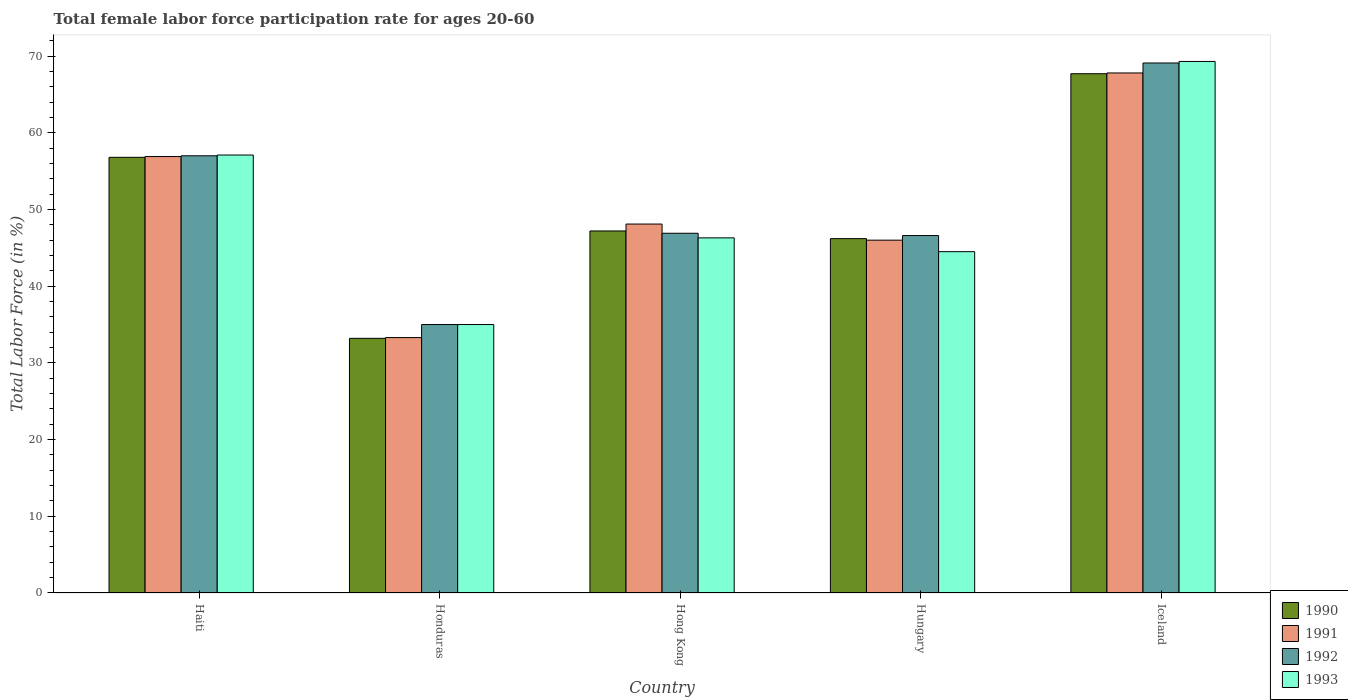How many groups of bars are there?
Your response must be concise. 5. What is the label of the 1st group of bars from the left?
Provide a short and direct response. Haiti. In how many cases, is the number of bars for a given country not equal to the number of legend labels?
Offer a terse response. 0. What is the female labor force participation rate in 1991 in Iceland?
Make the answer very short. 67.8. Across all countries, what is the maximum female labor force participation rate in 1990?
Make the answer very short. 67.7. In which country was the female labor force participation rate in 1991 minimum?
Provide a succinct answer. Honduras. What is the total female labor force participation rate in 1991 in the graph?
Your response must be concise. 252.1. What is the difference between the female labor force participation rate in 1993 in Hong Kong and that in Hungary?
Offer a terse response. 1.8. What is the difference between the female labor force participation rate in 1990 in Hungary and the female labor force participation rate in 1993 in Iceland?
Provide a short and direct response. -23.1. What is the average female labor force participation rate in 1990 per country?
Your answer should be compact. 50.22. What is the difference between the female labor force participation rate of/in 1993 and female labor force participation rate of/in 1992 in Hong Kong?
Your answer should be very brief. -0.6. In how many countries, is the female labor force participation rate in 1991 greater than 20 %?
Your answer should be very brief. 5. What is the ratio of the female labor force participation rate in 1990 in Haiti to that in Iceland?
Your answer should be compact. 0.84. Is the female labor force participation rate in 1991 in Haiti less than that in Honduras?
Your response must be concise. No. Is the difference between the female labor force participation rate in 1993 in Hungary and Iceland greater than the difference between the female labor force participation rate in 1992 in Hungary and Iceland?
Your answer should be very brief. No. What is the difference between the highest and the second highest female labor force participation rate in 1992?
Your answer should be very brief. -12.1. What is the difference between the highest and the lowest female labor force participation rate in 1992?
Offer a terse response. 34.1. In how many countries, is the female labor force participation rate in 1991 greater than the average female labor force participation rate in 1991 taken over all countries?
Your answer should be compact. 2. Is the sum of the female labor force participation rate in 1991 in Honduras and Hong Kong greater than the maximum female labor force participation rate in 1992 across all countries?
Your answer should be very brief. Yes. What does the 4th bar from the left in Honduras represents?
Your answer should be compact. 1993. What does the 1st bar from the right in Hungary represents?
Provide a short and direct response. 1993. How many countries are there in the graph?
Offer a terse response. 5. What is the difference between two consecutive major ticks on the Y-axis?
Keep it short and to the point. 10. Are the values on the major ticks of Y-axis written in scientific E-notation?
Make the answer very short. No. Does the graph contain any zero values?
Provide a short and direct response. No. Does the graph contain grids?
Give a very brief answer. No. Where does the legend appear in the graph?
Offer a terse response. Bottom right. What is the title of the graph?
Give a very brief answer. Total female labor force participation rate for ages 20-60. Does "2002" appear as one of the legend labels in the graph?
Your response must be concise. No. What is the Total Labor Force (in %) of 1990 in Haiti?
Give a very brief answer. 56.8. What is the Total Labor Force (in %) of 1991 in Haiti?
Keep it short and to the point. 56.9. What is the Total Labor Force (in %) in 1992 in Haiti?
Give a very brief answer. 57. What is the Total Labor Force (in %) in 1993 in Haiti?
Your answer should be compact. 57.1. What is the Total Labor Force (in %) in 1990 in Honduras?
Offer a very short reply. 33.2. What is the Total Labor Force (in %) of 1991 in Honduras?
Provide a succinct answer. 33.3. What is the Total Labor Force (in %) of 1993 in Honduras?
Give a very brief answer. 35. What is the Total Labor Force (in %) of 1990 in Hong Kong?
Your answer should be compact. 47.2. What is the Total Labor Force (in %) in 1991 in Hong Kong?
Provide a short and direct response. 48.1. What is the Total Labor Force (in %) in 1992 in Hong Kong?
Your answer should be compact. 46.9. What is the Total Labor Force (in %) in 1993 in Hong Kong?
Make the answer very short. 46.3. What is the Total Labor Force (in %) in 1990 in Hungary?
Offer a very short reply. 46.2. What is the Total Labor Force (in %) of 1992 in Hungary?
Your response must be concise. 46.6. What is the Total Labor Force (in %) of 1993 in Hungary?
Offer a terse response. 44.5. What is the Total Labor Force (in %) of 1990 in Iceland?
Make the answer very short. 67.7. What is the Total Labor Force (in %) of 1991 in Iceland?
Make the answer very short. 67.8. What is the Total Labor Force (in %) in 1992 in Iceland?
Your answer should be compact. 69.1. What is the Total Labor Force (in %) of 1993 in Iceland?
Give a very brief answer. 69.3. Across all countries, what is the maximum Total Labor Force (in %) in 1990?
Your answer should be very brief. 67.7. Across all countries, what is the maximum Total Labor Force (in %) in 1991?
Give a very brief answer. 67.8. Across all countries, what is the maximum Total Labor Force (in %) of 1992?
Provide a succinct answer. 69.1. Across all countries, what is the maximum Total Labor Force (in %) of 1993?
Provide a succinct answer. 69.3. Across all countries, what is the minimum Total Labor Force (in %) in 1990?
Offer a very short reply. 33.2. Across all countries, what is the minimum Total Labor Force (in %) in 1991?
Make the answer very short. 33.3. Across all countries, what is the minimum Total Labor Force (in %) of 1993?
Offer a very short reply. 35. What is the total Total Labor Force (in %) of 1990 in the graph?
Ensure brevity in your answer.  251.1. What is the total Total Labor Force (in %) of 1991 in the graph?
Offer a very short reply. 252.1. What is the total Total Labor Force (in %) in 1992 in the graph?
Your answer should be very brief. 254.6. What is the total Total Labor Force (in %) of 1993 in the graph?
Keep it short and to the point. 252.2. What is the difference between the Total Labor Force (in %) in 1990 in Haiti and that in Honduras?
Offer a very short reply. 23.6. What is the difference between the Total Labor Force (in %) of 1991 in Haiti and that in Honduras?
Offer a terse response. 23.6. What is the difference between the Total Labor Force (in %) of 1992 in Haiti and that in Honduras?
Give a very brief answer. 22. What is the difference between the Total Labor Force (in %) in 1993 in Haiti and that in Honduras?
Provide a succinct answer. 22.1. What is the difference between the Total Labor Force (in %) in 1991 in Haiti and that in Hong Kong?
Keep it short and to the point. 8.8. What is the difference between the Total Labor Force (in %) in 1992 in Haiti and that in Hong Kong?
Provide a succinct answer. 10.1. What is the difference between the Total Labor Force (in %) of 1993 in Haiti and that in Hong Kong?
Provide a succinct answer. 10.8. What is the difference between the Total Labor Force (in %) of 1990 in Haiti and that in Hungary?
Give a very brief answer. 10.6. What is the difference between the Total Labor Force (in %) of 1993 in Haiti and that in Hungary?
Give a very brief answer. 12.6. What is the difference between the Total Labor Force (in %) in 1991 in Haiti and that in Iceland?
Your answer should be compact. -10.9. What is the difference between the Total Labor Force (in %) in 1992 in Haiti and that in Iceland?
Offer a terse response. -12.1. What is the difference between the Total Labor Force (in %) of 1993 in Haiti and that in Iceland?
Your answer should be very brief. -12.2. What is the difference between the Total Labor Force (in %) in 1991 in Honduras and that in Hong Kong?
Provide a succinct answer. -14.8. What is the difference between the Total Labor Force (in %) of 1992 in Honduras and that in Hungary?
Offer a very short reply. -11.6. What is the difference between the Total Labor Force (in %) of 1993 in Honduras and that in Hungary?
Your answer should be compact. -9.5. What is the difference between the Total Labor Force (in %) of 1990 in Honduras and that in Iceland?
Ensure brevity in your answer.  -34.5. What is the difference between the Total Labor Force (in %) in 1991 in Honduras and that in Iceland?
Keep it short and to the point. -34.5. What is the difference between the Total Labor Force (in %) of 1992 in Honduras and that in Iceland?
Offer a very short reply. -34.1. What is the difference between the Total Labor Force (in %) in 1993 in Honduras and that in Iceland?
Offer a terse response. -34.3. What is the difference between the Total Labor Force (in %) in 1991 in Hong Kong and that in Hungary?
Offer a terse response. 2.1. What is the difference between the Total Labor Force (in %) in 1992 in Hong Kong and that in Hungary?
Your answer should be very brief. 0.3. What is the difference between the Total Labor Force (in %) of 1990 in Hong Kong and that in Iceland?
Provide a succinct answer. -20.5. What is the difference between the Total Labor Force (in %) of 1991 in Hong Kong and that in Iceland?
Ensure brevity in your answer.  -19.7. What is the difference between the Total Labor Force (in %) in 1992 in Hong Kong and that in Iceland?
Keep it short and to the point. -22.2. What is the difference between the Total Labor Force (in %) of 1993 in Hong Kong and that in Iceland?
Your answer should be very brief. -23. What is the difference between the Total Labor Force (in %) in 1990 in Hungary and that in Iceland?
Make the answer very short. -21.5. What is the difference between the Total Labor Force (in %) in 1991 in Hungary and that in Iceland?
Make the answer very short. -21.8. What is the difference between the Total Labor Force (in %) in 1992 in Hungary and that in Iceland?
Keep it short and to the point. -22.5. What is the difference between the Total Labor Force (in %) in 1993 in Hungary and that in Iceland?
Provide a succinct answer. -24.8. What is the difference between the Total Labor Force (in %) in 1990 in Haiti and the Total Labor Force (in %) in 1992 in Honduras?
Offer a terse response. 21.8. What is the difference between the Total Labor Force (in %) of 1990 in Haiti and the Total Labor Force (in %) of 1993 in Honduras?
Offer a terse response. 21.8. What is the difference between the Total Labor Force (in %) in 1991 in Haiti and the Total Labor Force (in %) in 1992 in Honduras?
Offer a very short reply. 21.9. What is the difference between the Total Labor Force (in %) in 1991 in Haiti and the Total Labor Force (in %) in 1993 in Honduras?
Give a very brief answer. 21.9. What is the difference between the Total Labor Force (in %) in 1992 in Haiti and the Total Labor Force (in %) in 1993 in Honduras?
Give a very brief answer. 22. What is the difference between the Total Labor Force (in %) of 1990 in Haiti and the Total Labor Force (in %) of 1993 in Hong Kong?
Keep it short and to the point. 10.5. What is the difference between the Total Labor Force (in %) of 1992 in Haiti and the Total Labor Force (in %) of 1993 in Hong Kong?
Keep it short and to the point. 10.7. What is the difference between the Total Labor Force (in %) in 1990 in Haiti and the Total Labor Force (in %) in 1991 in Hungary?
Offer a very short reply. 10.8. What is the difference between the Total Labor Force (in %) in 1990 in Haiti and the Total Labor Force (in %) in 1992 in Hungary?
Make the answer very short. 10.2. What is the difference between the Total Labor Force (in %) in 1991 in Haiti and the Total Labor Force (in %) in 1992 in Hungary?
Provide a succinct answer. 10.3. What is the difference between the Total Labor Force (in %) of 1990 in Haiti and the Total Labor Force (in %) of 1992 in Iceland?
Your response must be concise. -12.3. What is the difference between the Total Labor Force (in %) of 1990 in Haiti and the Total Labor Force (in %) of 1993 in Iceland?
Offer a terse response. -12.5. What is the difference between the Total Labor Force (in %) of 1991 in Haiti and the Total Labor Force (in %) of 1993 in Iceland?
Offer a terse response. -12.4. What is the difference between the Total Labor Force (in %) of 1992 in Haiti and the Total Labor Force (in %) of 1993 in Iceland?
Offer a very short reply. -12.3. What is the difference between the Total Labor Force (in %) in 1990 in Honduras and the Total Labor Force (in %) in 1991 in Hong Kong?
Your answer should be compact. -14.9. What is the difference between the Total Labor Force (in %) of 1990 in Honduras and the Total Labor Force (in %) of 1992 in Hong Kong?
Make the answer very short. -13.7. What is the difference between the Total Labor Force (in %) of 1990 in Honduras and the Total Labor Force (in %) of 1993 in Hong Kong?
Give a very brief answer. -13.1. What is the difference between the Total Labor Force (in %) of 1991 in Honduras and the Total Labor Force (in %) of 1992 in Hong Kong?
Keep it short and to the point. -13.6. What is the difference between the Total Labor Force (in %) of 1991 in Honduras and the Total Labor Force (in %) of 1993 in Hong Kong?
Offer a terse response. -13. What is the difference between the Total Labor Force (in %) in 1992 in Honduras and the Total Labor Force (in %) in 1993 in Hong Kong?
Provide a short and direct response. -11.3. What is the difference between the Total Labor Force (in %) of 1990 in Honduras and the Total Labor Force (in %) of 1992 in Hungary?
Give a very brief answer. -13.4. What is the difference between the Total Labor Force (in %) in 1990 in Honduras and the Total Labor Force (in %) in 1993 in Hungary?
Your answer should be compact. -11.3. What is the difference between the Total Labor Force (in %) of 1992 in Honduras and the Total Labor Force (in %) of 1993 in Hungary?
Provide a succinct answer. -9.5. What is the difference between the Total Labor Force (in %) in 1990 in Honduras and the Total Labor Force (in %) in 1991 in Iceland?
Your answer should be compact. -34.6. What is the difference between the Total Labor Force (in %) in 1990 in Honduras and the Total Labor Force (in %) in 1992 in Iceland?
Provide a succinct answer. -35.9. What is the difference between the Total Labor Force (in %) of 1990 in Honduras and the Total Labor Force (in %) of 1993 in Iceland?
Provide a short and direct response. -36.1. What is the difference between the Total Labor Force (in %) in 1991 in Honduras and the Total Labor Force (in %) in 1992 in Iceland?
Your answer should be compact. -35.8. What is the difference between the Total Labor Force (in %) of 1991 in Honduras and the Total Labor Force (in %) of 1993 in Iceland?
Offer a terse response. -36. What is the difference between the Total Labor Force (in %) of 1992 in Honduras and the Total Labor Force (in %) of 1993 in Iceland?
Keep it short and to the point. -34.3. What is the difference between the Total Labor Force (in %) in 1990 in Hong Kong and the Total Labor Force (in %) in 1992 in Hungary?
Make the answer very short. 0.6. What is the difference between the Total Labor Force (in %) of 1990 in Hong Kong and the Total Labor Force (in %) of 1993 in Hungary?
Offer a terse response. 2.7. What is the difference between the Total Labor Force (in %) in 1991 in Hong Kong and the Total Labor Force (in %) in 1993 in Hungary?
Ensure brevity in your answer.  3.6. What is the difference between the Total Labor Force (in %) in 1992 in Hong Kong and the Total Labor Force (in %) in 1993 in Hungary?
Make the answer very short. 2.4. What is the difference between the Total Labor Force (in %) in 1990 in Hong Kong and the Total Labor Force (in %) in 1991 in Iceland?
Your answer should be compact. -20.6. What is the difference between the Total Labor Force (in %) of 1990 in Hong Kong and the Total Labor Force (in %) of 1992 in Iceland?
Your response must be concise. -21.9. What is the difference between the Total Labor Force (in %) of 1990 in Hong Kong and the Total Labor Force (in %) of 1993 in Iceland?
Offer a terse response. -22.1. What is the difference between the Total Labor Force (in %) of 1991 in Hong Kong and the Total Labor Force (in %) of 1993 in Iceland?
Provide a succinct answer. -21.2. What is the difference between the Total Labor Force (in %) of 1992 in Hong Kong and the Total Labor Force (in %) of 1993 in Iceland?
Give a very brief answer. -22.4. What is the difference between the Total Labor Force (in %) in 1990 in Hungary and the Total Labor Force (in %) in 1991 in Iceland?
Offer a very short reply. -21.6. What is the difference between the Total Labor Force (in %) of 1990 in Hungary and the Total Labor Force (in %) of 1992 in Iceland?
Offer a terse response. -22.9. What is the difference between the Total Labor Force (in %) of 1990 in Hungary and the Total Labor Force (in %) of 1993 in Iceland?
Offer a very short reply. -23.1. What is the difference between the Total Labor Force (in %) in 1991 in Hungary and the Total Labor Force (in %) in 1992 in Iceland?
Provide a succinct answer. -23.1. What is the difference between the Total Labor Force (in %) in 1991 in Hungary and the Total Labor Force (in %) in 1993 in Iceland?
Offer a terse response. -23.3. What is the difference between the Total Labor Force (in %) in 1992 in Hungary and the Total Labor Force (in %) in 1993 in Iceland?
Give a very brief answer. -22.7. What is the average Total Labor Force (in %) of 1990 per country?
Give a very brief answer. 50.22. What is the average Total Labor Force (in %) of 1991 per country?
Your response must be concise. 50.42. What is the average Total Labor Force (in %) of 1992 per country?
Your response must be concise. 50.92. What is the average Total Labor Force (in %) in 1993 per country?
Ensure brevity in your answer.  50.44. What is the difference between the Total Labor Force (in %) in 1990 and Total Labor Force (in %) in 1993 in Haiti?
Your answer should be very brief. -0.3. What is the difference between the Total Labor Force (in %) of 1991 and Total Labor Force (in %) of 1993 in Haiti?
Make the answer very short. -0.2. What is the difference between the Total Labor Force (in %) in 1992 and Total Labor Force (in %) in 1993 in Haiti?
Make the answer very short. -0.1. What is the difference between the Total Labor Force (in %) in 1990 and Total Labor Force (in %) in 1991 in Honduras?
Give a very brief answer. -0.1. What is the difference between the Total Labor Force (in %) of 1990 and Total Labor Force (in %) of 1992 in Honduras?
Your answer should be compact. -1.8. What is the difference between the Total Labor Force (in %) of 1991 and Total Labor Force (in %) of 1992 in Honduras?
Your answer should be compact. -1.7. What is the difference between the Total Labor Force (in %) of 1992 and Total Labor Force (in %) of 1993 in Honduras?
Offer a terse response. 0. What is the difference between the Total Labor Force (in %) in 1990 and Total Labor Force (in %) in 1993 in Hong Kong?
Ensure brevity in your answer.  0.9. What is the difference between the Total Labor Force (in %) in 1991 and Total Labor Force (in %) in 1993 in Hong Kong?
Provide a short and direct response. 1.8. What is the difference between the Total Labor Force (in %) of 1992 and Total Labor Force (in %) of 1993 in Hong Kong?
Your response must be concise. 0.6. What is the difference between the Total Labor Force (in %) of 1990 and Total Labor Force (in %) of 1991 in Hungary?
Provide a short and direct response. 0.2. What is the difference between the Total Labor Force (in %) in 1990 and Total Labor Force (in %) in 1992 in Hungary?
Offer a terse response. -0.4. What is the difference between the Total Labor Force (in %) in 1991 and Total Labor Force (in %) in 1992 in Hungary?
Provide a succinct answer. -0.6. What is the difference between the Total Labor Force (in %) of 1991 and Total Labor Force (in %) of 1993 in Hungary?
Your response must be concise. 1.5. What is the difference between the Total Labor Force (in %) in 1992 and Total Labor Force (in %) in 1993 in Hungary?
Make the answer very short. 2.1. What is the difference between the Total Labor Force (in %) of 1990 and Total Labor Force (in %) of 1992 in Iceland?
Make the answer very short. -1.4. What is the difference between the Total Labor Force (in %) of 1990 and Total Labor Force (in %) of 1993 in Iceland?
Your response must be concise. -1.6. What is the ratio of the Total Labor Force (in %) of 1990 in Haiti to that in Honduras?
Offer a terse response. 1.71. What is the ratio of the Total Labor Force (in %) of 1991 in Haiti to that in Honduras?
Provide a succinct answer. 1.71. What is the ratio of the Total Labor Force (in %) of 1992 in Haiti to that in Honduras?
Ensure brevity in your answer.  1.63. What is the ratio of the Total Labor Force (in %) of 1993 in Haiti to that in Honduras?
Give a very brief answer. 1.63. What is the ratio of the Total Labor Force (in %) in 1990 in Haiti to that in Hong Kong?
Make the answer very short. 1.2. What is the ratio of the Total Labor Force (in %) in 1991 in Haiti to that in Hong Kong?
Offer a very short reply. 1.18. What is the ratio of the Total Labor Force (in %) of 1992 in Haiti to that in Hong Kong?
Provide a succinct answer. 1.22. What is the ratio of the Total Labor Force (in %) of 1993 in Haiti to that in Hong Kong?
Offer a very short reply. 1.23. What is the ratio of the Total Labor Force (in %) of 1990 in Haiti to that in Hungary?
Offer a terse response. 1.23. What is the ratio of the Total Labor Force (in %) in 1991 in Haiti to that in Hungary?
Offer a very short reply. 1.24. What is the ratio of the Total Labor Force (in %) of 1992 in Haiti to that in Hungary?
Ensure brevity in your answer.  1.22. What is the ratio of the Total Labor Force (in %) of 1993 in Haiti to that in Hungary?
Ensure brevity in your answer.  1.28. What is the ratio of the Total Labor Force (in %) in 1990 in Haiti to that in Iceland?
Make the answer very short. 0.84. What is the ratio of the Total Labor Force (in %) in 1991 in Haiti to that in Iceland?
Ensure brevity in your answer.  0.84. What is the ratio of the Total Labor Force (in %) in 1992 in Haiti to that in Iceland?
Provide a short and direct response. 0.82. What is the ratio of the Total Labor Force (in %) of 1993 in Haiti to that in Iceland?
Provide a short and direct response. 0.82. What is the ratio of the Total Labor Force (in %) in 1990 in Honduras to that in Hong Kong?
Make the answer very short. 0.7. What is the ratio of the Total Labor Force (in %) of 1991 in Honduras to that in Hong Kong?
Give a very brief answer. 0.69. What is the ratio of the Total Labor Force (in %) in 1992 in Honduras to that in Hong Kong?
Ensure brevity in your answer.  0.75. What is the ratio of the Total Labor Force (in %) in 1993 in Honduras to that in Hong Kong?
Your response must be concise. 0.76. What is the ratio of the Total Labor Force (in %) of 1990 in Honduras to that in Hungary?
Your answer should be very brief. 0.72. What is the ratio of the Total Labor Force (in %) in 1991 in Honduras to that in Hungary?
Offer a very short reply. 0.72. What is the ratio of the Total Labor Force (in %) in 1992 in Honduras to that in Hungary?
Provide a short and direct response. 0.75. What is the ratio of the Total Labor Force (in %) of 1993 in Honduras to that in Hungary?
Provide a succinct answer. 0.79. What is the ratio of the Total Labor Force (in %) in 1990 in Honduras to that in Iceland?
Make the answer very short. 0.49. What is the ratio of the Total Labor Force (in %) in 1991 in Honduras to that in Iceland?
Provide a short and direct response. 0.49. What is the ratio of the Total Labor Force (in %) in 1992 in Honduras to that in Iceland?
Provide a short and direct response. 0.51. What is the ratio of the Total Labor Force (in %) of 1993 in Honduras to that in Iceland?
Give a very brief answer. 0.51. What is the ratio of the Total Labor Force (in %) in 1990 in Hong Kong to that in Hungary?
Provide a short and direct response. 1.02. What is the ratio of the Total Labor Force (in %) of 1991 in Hong Kong to that in Hungary?
Your answer should be very brief. 1.05. What is the ratio of the Total Labor Force (in %) of 1992 in Hong Kong to that in Hungary?
Provide a short and direct response. 1.01. What is the ratio of the Total Labor Force (in %) in 1993 in Hong Kong to that in Hungary?
Provide a short and direct response. 1.04. What is the ratio of the Total Labor Force (in %) of 1990 in Hong Kong to that in Iceland?
Offer a very short reply. 0.7. What is the ratio of the Total Labor Force (in %) of 1991 in Hong Kong to that in Iceland?
Make the answer very short. 0.71. What is the ratio of the Total Labor Force (in %) of 1992 in Hong Kong to that in Iceland?
Make the answer very short. 0.68. What is the ratio of the Total Labor Force (in %) of 1993 in Hong Kong to that in Iceland?
Your answer should be very brief. 0.67. What is the ratio of the Total Labor Force (in %) in 1990 in Hungary to that in Iceland?
Offer a very short reply. 0.68. What is the ratio of the Total Labor Force (in %) in 1991 in Hungary to that in Iceland?
Keep it short and to the point. 0.68. What is the ratio of the Total Labor Force (in %) in 1992 in Hungary to that in Iceland?
Ensure brevity in your answer.  0.67. What is the ratio of the Total Labor Force (in %) in 1993 in Hungary to that in Iceland?
Keep it short and to the point. 0.64. What is the difference between the highest and the second highest Total Labor Force (in %) in 1992?
Offer a very short reply. 12.1. What is the difference between the highest and the second highest Total Labor Force (in %) of 1993?
Your answer should be compact. 12.2. What is the difference between the highest and the lowest Total Labor Force (in %) of 1990?
Offer a terse response. 34.5. What is the difference between the highest and the lowest Total Labor Force (in %) in 1991?
Give a very brief answer. 34.5. What is the difference between the highest and the lowest Total Labor Force (in %) in 1992?
Ensure brevity in your answer.  34.1. What is the difference between the highest and the lowest Total Labor Force (in %) of 1993?
Ensure brevity in your answer.  34.3. 